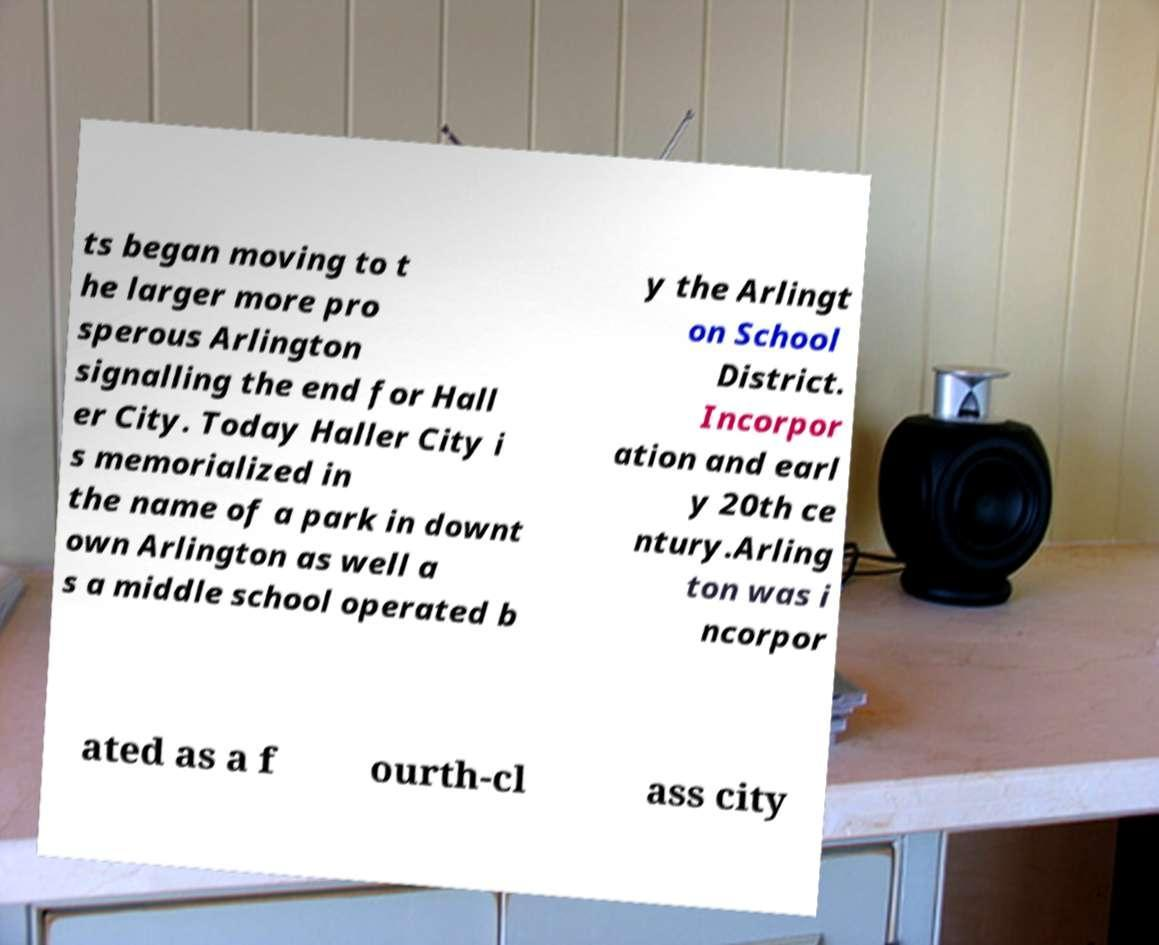Please read and relay the text visible in this image. What does it say? ts began moving to t he larger more pro sperous Arlington signalling the end for Hall er City. Today Haller City i s memorialized in the name of a park in downt own Arlington as well a s a middle school operated b y the Arlingt on School District. Incorpor ation and earl y 20th ce ntury.Arling ton was i ncorpor ated as a f ourth-cl ass city 